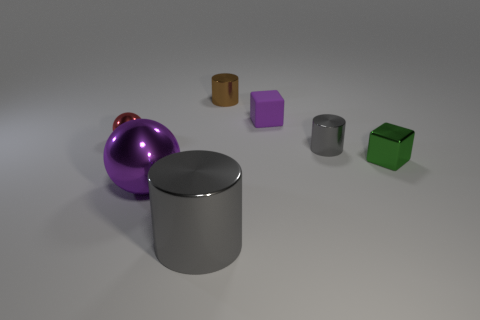What is the material of the object that is the same color as the large metal sphere?
Your answer should be very brief. Rubber. Are there any red objects that are to the right of the object that is to the left of the large purple shiny ball?
Offer a terse response. No. Do the brown shiny thing and the purple object that is in front of the purple cube have the same shape?
Provide a succinct answer. No. The shiny cylinder that is to the left of the brown metal cylinder is what color?
Ensure brevity in your answer.  Gray. How big is the cube in front of the sphere that is behind the green shiny thing?
Keep it short and to the point. Small. Do the purple object that is to the left of the small brown metallic thing and the red metallic object have the same shape?
Your response must be concise. Yes. What is the material of the purple thing that is the same shape as the green object?
Provide a succinct answer. Rubber. How many objects are either small metallic cylinders in front of the small metal sphere or gray shiny cylinders in front of the tiny green cube?
Give a very brief answer. 2. Does the tiny rubber block have the same color as the large ball on the left side of the large gray metallic cylinder?
Your answer should be compact. Yes. What is the shape of the brown thing that is the same material as the big sphere?
Make the answer very short. Cylinder. 